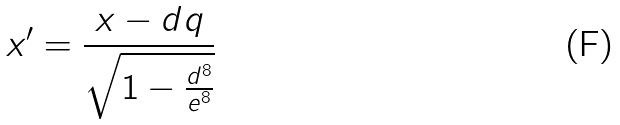<formula> <loc_0><loc_0><loc_500><loc_500>x ^ { \prime } = \frac { x - d q } { \sqrt { 1 - \frac { d ^ { 8 } } { e ^ { 8 } } } }</formula> 